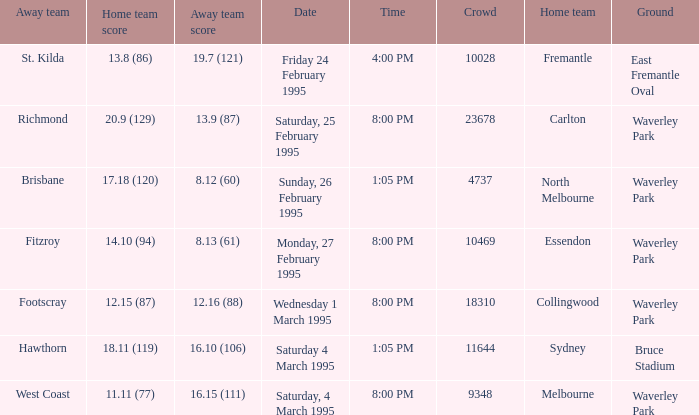Name the ground for essendon Waverley Park. 